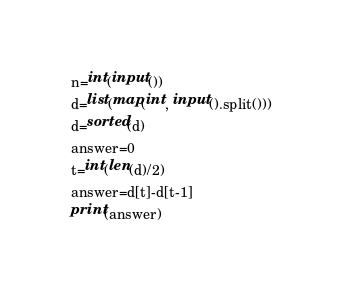Convert code to text. <code><loc_0><loc_0><loc_500><loc_500><_Python_>n=int(input())
d=list(map(int, input().split()))
d=sorted(d)
answer=0
t=int(len(d)/2)
answer=d[t]-d[t-1]
print(answer)</code> 